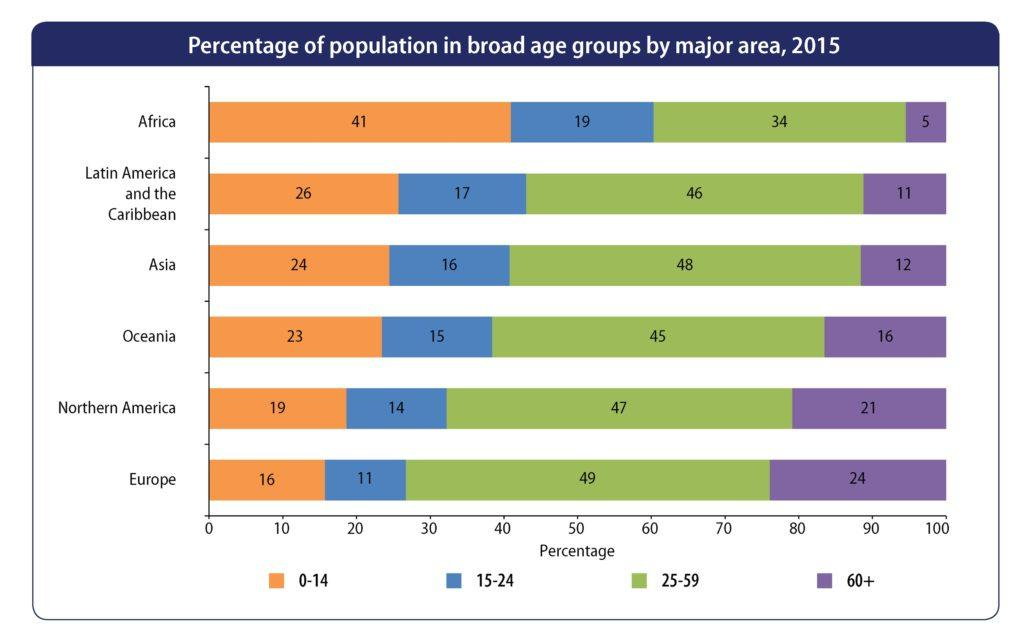Indicate a few pertinent items in this graphic. The total percentage of people aged 25 or above in Europe is 73%. In Oceania, the least populous age group is 15-24. According to a recent estimate, approximately 34% of the population in Africa falls within the age range of 25 and 59 years old. Latin America and the Caribbean has the least populous age group of 60 and above. The age group of 25-59 is the most populous in Asia. 